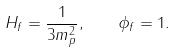Convert formula to latex. <formula><loc_0><loc_0><loc_500><loc_500>H _ { f } = \frac { 1 } { 3 m _ { p } ^ { 2 } } , \quad \phi _ { f } = 1 .</formula> 